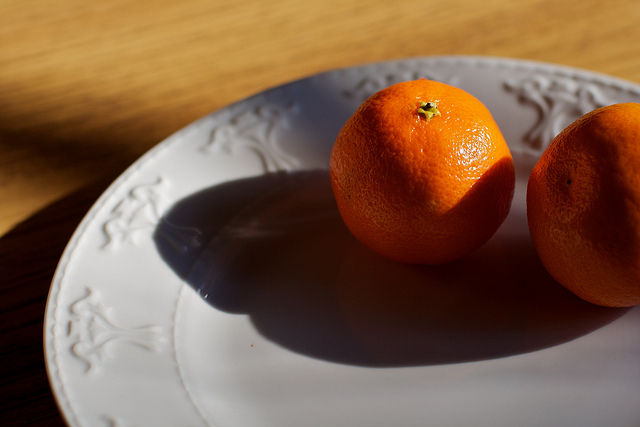Describe a realistic scenario involving this image in a short response. This image likely captures a peaceful moment in a cozy home, where someone has placed fresh oranges on a beautifully designed plate, ready to prepare a healthy breakfast or snack. 